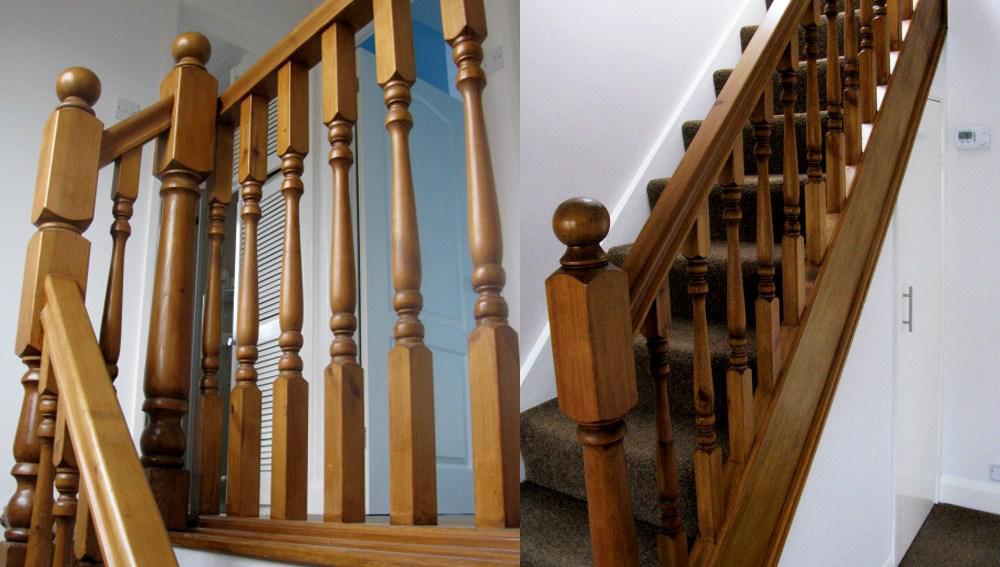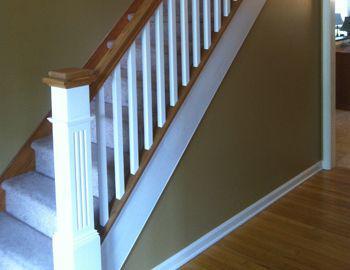The first image is the image on the left, the second image is the image on the right. For the images displayed, is the sentence "All of the staircases have vertical banisters for support." factually correct? Answer yes or no. Yes. The first image is the image on the left, the second image is the image on the right. Examine the images to the left and right. Is the description "Each staircase has a banister." accurate? Answer yes or no. Yes. 